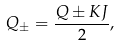<formula> <loc_0><loc_0><loc_500><loc_500>Q _ { \pm } = \frac { Q \pm K J } { 2 } ,</formula> 